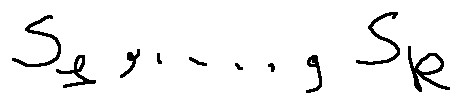Convert formula to latex. <formula><loc_0><loc_0><loc_500><loc_500>s _ { 1 } , \dots , s _ { k }</formula> 